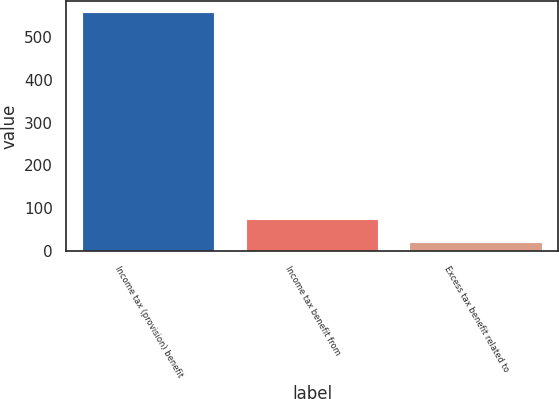Convert chart to OTSL. <chart><loc_0><loc_0><loc_500><loc_500><bar_chart><fcel>Income tax (provision) benefit<fcel>Income tax benefit from<fcel>Excess tax benefit related to<nl><fcel>556<fcel>72.7<fcel>19<nl></chart> 